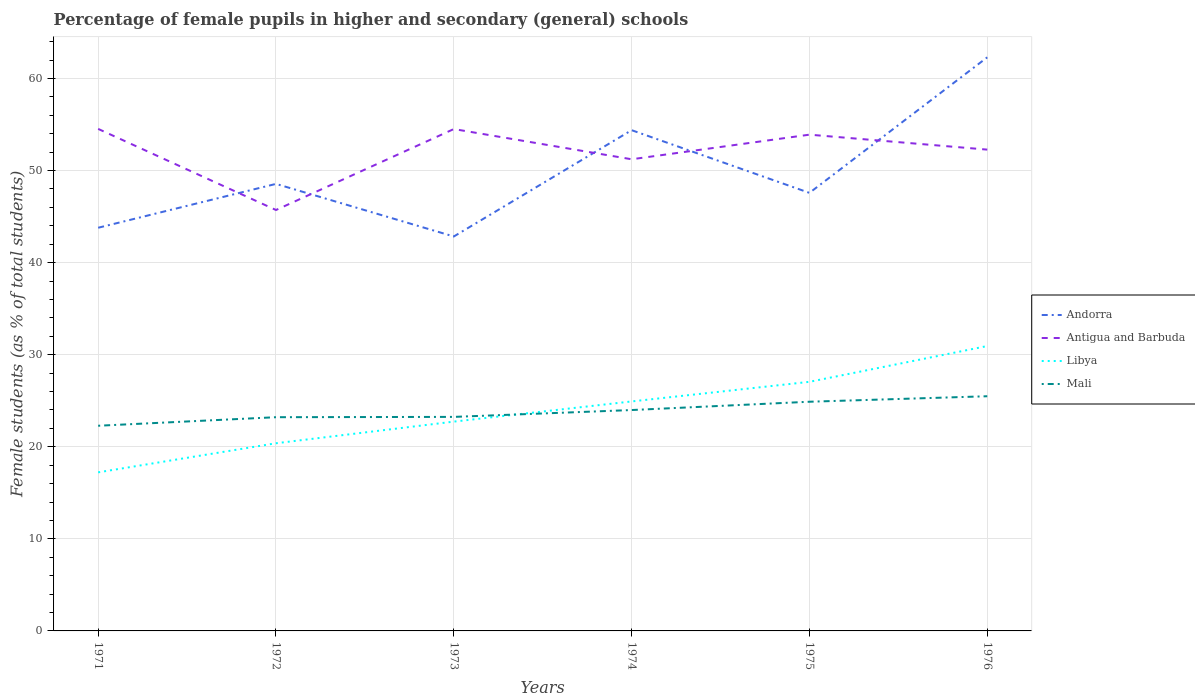Does the line corresponding to Mali intersect with the line corresponding to Libya?
Provide a succinct answer. Yes. Across all years, what is the maximum percentage of female pupils in higher and secondary schools in Andorra?
Make the answer very short. 42.84. What is the total percentage of female pupils in higher and secondary schools in Antigua and Barbuda in the graph?
Ensure brevity in your answer.  3.3. What is the difference between the highest and the second highest percentage of female pupils in higher and secondary schools in Antigua and Barbuda?
Provide a succinct answer. 8.81. What is the difference between the highest and the lowest percentage of female pupils in higher and secondary schools in Mali?
Make the answer very short. 3. How many lines are there?
Your answer should be compact. 4. How many years are there in the graph?
Offer a very short reply. 6. What is the difference between two consecutive major ticks on the Y-axis?
Your response must be concise. 10. Are the values on the major ticks of Y-axis written in scientific E-notation?
Offer a very short reply. No. Does the graph contain grids?
Give a very brief answer. Yes. Where does the legend appear in the graph?
Your answer should be very brief. Center right. How many legend labels are there?
Your answer should be very brief. 4. How are the legend labels stacked?
Your response must be concise. Vertical. What is the title of the graph?
Offer a terse response. Percentage of female pupils in higher and secondary (general) schools. What is the label or title of the Y-axis?
Make the answer very short. Female students (as % of total students). What is the Female students (as % of total students) of Andorra in 1971?
Give a very brief answer. 43.78. What is the Female students (as % of total students) of Antigua and Barbuda in 1971?
Offer a terse response. 54.52. What is the Female students (as % of total students) of Libya in 1971?
Provide a short and direct response. 17.22. What is the Female students (as % of total students) in Mali in 1971?
Offer a terse response. 22.28. What is the Female students (as % of total students) in Andorra in 1972?
Offer a very short reply. 48.55. What is the Female students (as % of total students) of Antigua and Barbuda in 1972?
Give a very brief answer. 45.71. What is the Female students (as % of total students) of Libya in 1972?
Give a very brief answer. 20.38. What is the Female students (as % of total students) of Mali in 1972?
Your response must be concise. 23.21. What is the Female students (as % of total students) of Andorra in 1973?
Make the answer very short. 42.84. What is the Female students (as % of total students) in Antigua and Barbuda in 1973?
Keep it short and to the point. 54.5. What is the Female students (as % of total students) of Libya in 1973?
Your answer should be compact. 22.73. What is the Female students (as % of total students) in Mali in 1973?
Offer a terse response. 23.24. What is the Female students (as % of total students) of Andorra in 1974?
Ensure brevity in your answer.  54.38. What is the Female students (as % of total students) of Antigua and Barbuda in 1974?
Provide a short and direct response. 51.22. What is the Female students (as % of total students) of Libya in 1974?
Your response must be concise. 24.92. What is the Female students (as % of total students) of Mali in 1974?
Provide a short and direct response. 23.99. What is the Female students (as % of total students) of Andorra in 1975?
Keep it short and to the point. 47.57. What is the Female students (as % of total students) of Antigua and Barbuda in 1975?
Your answer should be very brief. 53.89. What is the Female students (as % of total students) in Libya in 1975?
Offer a very short reply. 27.05. What is the Female students (as % of total students) of Mali in 1975?
Make the answer very short. 24.89. What is the Female students (as % of total students) of Andorra in 1976?
Provide a succinct answer. 62.29. What is the Female students (as % of total students) of Antigua and Barbuda in 1976?
Keep it short and to the point. 52.27. What is the Female students (as % of total students) in Libya in 1976?
Your response must be concise. 30.94. What is the Female students (as % of total students) of Mali in 1976?
Keep it short and to the point. 25.49. Across all years, what is the maximum Female students (as % of total students) of Andorra?
Keep it short and to the point. 62.29. Across all years, what is the maximum Female students (as % of total students) in Antigua and Barbuda?
Your answer should be compact. 54.52. Across all years, what is the maximum Female students (as % of total students) of Libya?
Make the answer very short. 30.94. Across all years, what is the maximum Female students (as % of total students) of Mali?
Your response must be concise. 25.49. Across all years, what is the minimum Female students (as % of total students) in Andorra?
Offer a very short reply. 42.84. Across all years, what is the minimum Female students (as % of total students) of Antigua and Barbuda?
Your response must be concise. 45.71. Across all years, what is the minimum Female students (as % of total students) of Libya?
Your answer should be compact. 17.22. Across all years, what is the minimum Female students (as % of total students) of Mali?
Your response must be concise. 22.28. What is the total Female students (as % of total students) in Andorra in the graph?
Your response must be concise. 299.42. What is the total Female students (as % of total students) in Antigua and Barbuda in the graph?
Provide a succinct answer. 312.12. What is the total Female students (as % of total students) of Libya in the graph?
Make the answer very short. 143.25. What is the total Female students (as % of total students) of Mali in the graph?
Provide a short and direct response. 143.1. What is the difference between the Female students (as % of total students) in Andorra in 1971 and that in 1972?
Your answer should be very brief. -4.76. What is the difference between the Female students (as % of total students) of Antigua and Barbuda in 1971 and that in 1972?
Give a very brief answer. 8.81. What is the difference between the Female students (as % of total students) of Libya in 1971 and that in 1972?
Your answer should be very brief. -3.16. What is the difference between the Female students (as % of total students) in Mali in 1971 and that in 1972?
Make the answer very short. -0.93. What is the difference between the Female students (as % of total students) in Andorra in 1971 and that in 1973?
Offer a terse response. 0.95. What is the difference between the Female students (as % of total students) of Antigua and Barbuda in 1971 and that in 1973?
Your answer should be compact. 0.02. What is the difference between the Female students (as % of total students) in Libya in 1971 and that in 1973?
Offer a terse response. -5.51. What is the difference between the Female students (as % of total students) in Mali in 1971 and that in 1973?
Give a very brief answer. -0.96. What is the difference between the Female students (as % of total students) of Andorra in 1971 and that in 1974?
Your answer should be very brief. -10.6. What is the difference between the Female students (as % of total students) of Antigua and Barbuda in 1971 and that in 1974?
Your response must be concise. 3.3. What is the difference between the Female students (as % of total students) in Libya in 1971 and that in 1974?
Your response must be concise. -7.7. What is the difference between the Female students (as % of total students) of Mali in 1971 and that in 1974?
Keep it short and to the point. -1.71. What is the difference between the Female students (as % of total students) of Andorra in 1971 and that in 1975?
Make the answer very short. -3.79. What is the difference between the Female students (as % of total students) in Antigua and Barbuda in 1971 and that in 1975?
Your answer should be very brief. 0.63. What is the difference between the Female students (as % of total students) in Libya in 1971 and that in 1975?
Offer a terse response. -9.83. What is the difference between the Female students (as % of total students) of Mali in 1971 and that in 1975?
Your answer should be very brief. -2.61. What is the difference between the Female students (as % of total students) of Andorra in 1971 and that in 1976?
Provide a succinct answer. -18.51. What is the difference between the Female students (as % of total students) in Antigua and Barbuda in 1971 and that in 1976?
Make the answer very short. 2.25. What is the difference between the Female students (as % of total students) of Libya in 1971 and that in 1976?
Ensure brevity in your answer.  -13.72. What is the difference between the Female students (as % of total students) in Mali in 1971 and that in 1976?
Make the answer very short. -3.2. What is the difference between the Female students (as % of total students) of Andorra in 1972 and that in 1973?
Offer a terse response. 5.71. What is the difference between the Female students (as % of total students) in Antigua and Barbuda in 1972 and that in 1973?
Provide a succinct answer. -8.79. What is the difference between the Female students (as % of total students) of Libya in 1972 and that in 1973?
Your response must be concise. -2.35. What is the difference between the Female students (as % of total students) in Mali in 1972 and that in 1973?
Provide a short and direct response. -0.03. What is the difference between the Female students (as % of total students) in Andorra in 1972 and that in 1974?
Provide a short and direct response. -5.83. What is the difference between the Female students (as % of total students) of Antigua and Barbuda in 1972 and that in 1974?
Provide a succinct answer. -5.51. What is the difference between the Female students (as % of total students) of Libya in 1972 and that in 1974?
Make the answer very short. -4.54. What is the difference between the Female students (as % of total students) in Mali in 1972 and that in 1974?
Provide a short and direct response. -0.78. What is the difference between the Female students (as % of total students) of Andorra in 1972 and that in 1975?
Your answer should be very brief. 0.97. What is the difference between the Female students (as % of total students) of Antigua and Barbuda in 1972 and that in 1975?
Offer a very short reply. -8.18. What is the difference between the Female students (as % of total students) in Libya in 1972 and that in 1975?
Your answer should be compact. -6.67. What is the difference between the Female students (as % of total students) of Mali in 1972 and that in 1975?
Keep it short and to the point. -1.68. What is the difference between the Female students (as % of total students) in Andorra in 1972 and that in 1976?
Your answer should be compact. -13.75. What is the difference between the Female students (as % of total students) of Antigua and Barbuda in 1972 and that in 1976?
Make the answer very short. -6.56. What is the difference between the Female students (as % of total students) in Libya in 1972 and that in 1976?
Give a very brief answer. -10.56. What is the difference between the Female students (as % of total students) of Mali in 1972 and that in 1976?
Give a very brief answer. -2.28. What is the difference between the Female students (as % of total students) in Andorra in 1973 and that in 1974?
Offer a very short reply. -11.55. What is the difference between the Female students (as % of total students) in Antigua and Barbuda in 1973 and that in 1974?
Provide a succinct answer. 3.28. What is the difference between the Female students (as % of total students) of Libya in 1973 and that in 1974?
Provide a short and direct response. -2.19. What is the difference between the Female students (as % of total students) of Mali in 1973 and that in 1974?
Your answer should be compact. -0.74. What is the difference between the Female students (as % of total students) in Andorra in 1973 and that in 1975?
Your answer should be compact. -4.74. What is the difference between the Female students (as % of total students) in Antigua and Barbuda in 1973 and that in 1975?
Ensure brevity in your answer.  0.61. What is the difference between the Female students (as % of total students) of Libya in 1973 and that in 1975?
Your response must be concise. -4.32. What is the difference between the Female students (as % of total students) in Mali in 1973 and that in 1975?
Make the answer very short. -1.65. What is the difference between the Female students (as % of total students) in Andorra in 1973 and that in 1976?
Keep it short and to the point. -19.46. What is the difference between the Female students (as % of total students) of Antigua and Barbuda in 1973 and that in 1976?
Give a very brief answer. 2.23. What is the difference between the Female students (as % of total students) of Libya in 1973 and that in 1976?
Provide a succinct answer. -8.21. What is the difference between the Female students (as % of total students) of Mali in 1973 and that in 1976?
Your answer should be compact. -2.24. What is the difference between the Female students (as % of total students) of Andorra in 1974 and that in 1975?
Provide a succinct answer. 6.81. What is the difference between the Female students (as % of total students) in Antigua and Barbuda in 1974 and that in 1975?
Keep it short and to the point. -2.67. What is the difference between the Female students (as % of total students) of Libya in 1974 and that in 1975?
Give a very brief answer. -2.13. What is the difference between the Female students (as % of total students) of Mali in 1974 and that in 1975?
Give a very brief answer. -0.9. What is the difference between the Female students (as % of total students) in Andorra in 1974 and that in 1976?
Your answer should be compact. -7.91. What is the difference between the Female students (as % of total students) in Antigua and Barbuda in 1974 and that in 1976?
Your response must be concise. -1.05. What is the difference between the Female students (as % of total students) in Libya in 1974 and that in 1976?
Ensure brevity in your answer.  -6.02. What is the difference between the Female students (as % of total students) in Mali in 1974 and that in 1976?
Provide a short and direct response. -1.5. What is the difference between the Female students (as % of total students) in Andorra in 1975 and that in 1976?
Your answer should be compact. -14.72. What is the difference between the Female students (as % of total students) of Antigua and Barbuda in 1975 and that in 1976?
Offer a very short reply. 1.62. What is the difference between the Female students (as % of total students) of Libya in 1975 and that in 1976?
Ensure brevity in your answer.  -3.89. What is the difference between the Female students (as % of total students) of Mali in 1975 and that in 1976?
Make the answer very short. -0.6. What is the difference between the Female students (as % of total students) in Andorra in 1971 and the Female students (as % of total students) in Antigua and Barbuda in 1972?
Your response must be concise. -1.93. What is the difference between the Female students (as % of total students) in Andorra in 1971 and the Female students (as % of total students) in Libya in 1972?
Give a very brief answer. 23.4. What is the difference between the Female students (as % of total students) of Andorra in 1971 and the Female students (as % of total students) of Mali in 1972?
Offer a very short reply. 20.57. What is the difference between the Female students (as % of total students) in Antigua and Barbuda in 1971 and the Female students (as % of total students) in Libya in 1972?
Offer a very short reply. 34.14. What is the difference between the Female students (as % of total students) in Antigua and Barbuda in 1971 and the Female students (as % of total students) in Mali in 1972?
Keep it short and to the point. 31.31. What is the difference between the Female students (as % of total students) in Libya in 1971 and the Female students (as % of total students) in Mali in 1972?
Give a very brief answer. -5.99. What is the difference between the Female students (as % of total students) of Andorra in 1971 and the Female students (as % of total students) of Antigua and Barbuda in 1973?
Your response must be concise. -10.72. What is the difference between the Female students (as % of total students) in Andorra in 1971 and the Female students (as % of total students) in Libya in 1973?
Make the answer very short. 21.05. What is the difference between the Female students (as % of total students) in Andorra in 1971 and the Female students (as % of total students) in Mali in 1973?
Provide a succinct answer. 20.54. What is the difference between the Female students (as % of total students) of Antigua and Barbuda in 1971 and the Female students (as % of total students) of Libya in 1973?
Keep it short and to the point. 31.79. What is the difference between the Female students (as % of total students) of Antigua and Barbuda in 1971 and the Female students (as % of total students) of Mali in 1973?
Provide a short and direct response. 31.28. What is the difference between the Female students (as % of total students) of Libya in 1971 and the Female students (as % of total students) of Mali in 1973?
Your answer should be compact. -6.02. What is the difference between the Female students (as % of total students) of Andorra in 1971 and the Female students (as % of total students) of Antigua and Barbuda in 1974?
Offer a very short reply. -7.44. What is the difference between the Female students (as % of total students) in Andorra in 1971 and the Female students (as % of total students) in Libya in 1974?
Provide a succinct answer. 18.86. What is the difference between the Female students (as % of total students) in Andorra in 1971 and the Female students (as % of total students) in Mali in 1974?
Keep it short and to the point. 19.8. What is the difference between the Female students (as % of total students) of Antigua and Barbuda in 1971 and the Female students (as % of total students) of Libya in 1974?
Your response must be concise. 29.6. What is the difference between the Female students (as % of total students) in Antigua and Barbuda in 1971 and the Female students (as % of total students) in Mali in 1974?
Keep it short and to the point. 30.53. What is the difference between the Female students (as % of total students) in Libya in 1971 and the Female students (as % of total students) in Mali in 1974?
Offer a very short reply. -6.77. What is the difference between the Female students (as % of total students) of Andorra in 1971 and the Female students (as % of total students) of Antigua and Barbuda in 1975?
Provide a succinct answer. -10.11. What is the difference between the Female students (as % of total students) of Andorra in 1971 and the Female students (as % of total students) of Libya in 1975?
Ensure brevity in your answer.  16.73. What is the difference between the Female students (as % of total students) of Andorra in 1971 and the Female students (as % of total students) of Mali in 1975?
Provide a short and direct response. 18.89. What is the difference between the Female students (as % of total students) of Antigua and Barbuda in 1971 and the Female students (as % of total students) of Libya in 1975?
Offer a very short reply. 27.47. What is the difference between the Female students (as % of total students) in Antigua and Barbuda in 1971 and the Female students (as % of total students) in Mali in 1975?
Ensure brevity in your answer.  29.63. What is the difference between the Female students (as % of total students) of Libya in 1971 and the Female students (as % of total students) of Mali in 1975?
Make the answer very short. -7.67. What is the difference between the Female students (as % of total students) of Andorra in 1971 and the Female students (as % of total students) of Antigua and Barbuda in 1976?
Your answer should be compact. -8.49. What is the difference between the Female students (as % of total students) in Andorra in 1971 and the Female students (as % of total students) in Libya in 1976?
Your answer should be compact. 12.85. What is the difference between the Female students (as % of total students) of Andorra in 1971 and the Female students (as % of total students) of Mali in 1976?
Provide a succinct answer. 18.3. What is the difference between the Female students (as % of total students) of Antigua and Barbuda in 1971 and the Female students (as % of total students) of Libya in 1976?
Keep it short and to the point. 23.58. What is the difference between the Female students (as % of total students) in Antigua and Barbuda in 1971 and the Female students (as % of total students) in Mali in 1976?
Your answer should be very brief. 29.03. What is the difference between the Female students (as % of total students) in Libya in 1971 and the Female students (as % of total students) in Mali in 1976?
Your answer should be very brief. -8.26. What is the difference between the Female students (as % of total students) of Andorra in 1972 and the Female students (as % of total students) of Antigua and Barbuda in 1973?
Your answer should be very brief. -5.96. What is the difference between the Female students (as % of total students) of Andorra in 1972 and the Female students (as % of total students) of Libya in 1973?
Give a very brief answer. 25.82. What is the difference between the Female students (as % of total students) in Andorra in 1972 and the Female students (as % of total students) in Mali in 1973?
Your response must be concise. 25.3. What is the difference between the Female students (as % of total students) of Antigua and Barbuda in 1972 and the Female students (as % of total students) of Libya in 1973?
Provide a succinct answer. 22.98. What is the difference between the Female students (as % of total students) in Antigua and Barbuda in 1972 and the Female students (as % of total students) in Mali in 1973?
Provide a succinct answer. 22.47. What is the difference between the Female students (as % of total students) of Libya in 1972 and the Female students (as % of total students) of Mali in 1973?
Your answer should be compact. -2.86. What is the difference between the Female students (as % of total students) of Andorra in 1972 and the Female students (as % of total students) of Antigua and Barbuda in 1974?
Offer a very short reply. -2.67. What is the difference between the Female students (as % of total students) in Andorra in 1972 and the Female students (as % of total students) in Libya in 1974?
Offer a terse response. 23.62. What is the difference between the Female students (as % of total students) in Andorra in 1972 and the Female students (as % of total students) in Mali in 1974?
Keep it short and to the point. 24.56. What is the difference between the Female students (as % of total students) of Antigua and Barbuda in 1972 and the Female students (as % of total students) of Libya in 1974?
Keep it short and to the point. 20.79. What is the difference between the Female students (as % of total students) of Antigua and Barbuda in 1972 and the Female students (as % of total students) of Mali in 1974?
Provide a succinct answer. 21.72. What is the difference between the Female students (as % of total students) in Libya in 1972 and the Female students (as % of total students) in Mali in 1974?
Make the answer very short. -3.61. What is the difference between the Female students (as % of total students) of Andorra in 1972 and the Female students (as % of total students) of Antigua and Barbuda in 1975?
Give a very brief answer. -5.35. What is the difference between the Female students (as % of total students) in Andorra in 1972 and the Female students (as % of total students) in Libya in 1975?
Keep it short and to the point. 21.5. What is the difference between the Female students (as % of total students) of Andorra in 1972 and the Female students (as % of total students) of Mali in 1975?
Provide a succinct answer. 23.66. What is the difference between the Female students (as % of total students) in Antigua and Barbuda in 1972 and the Female students (as % of total students) in Libya in 1975?
Keep it short and to the point. 18.66. What is the difference between the Female students (as % of total students) of Antigua and Barbuda in 1972 and the Female students (as % of total students) of Mali in 1975?
Provide a short and direct response. 20.82. What is the difference between the Female students (as % of total students) of Libya in 1972 and the Female students (as % of total students) of Mali in 1975?
Your answer should be very brief. -4.51. What is the difference between the Female students (as % of total students) of Andorra in 1972 and the Female students (as % of total students) of Antigua and Barbuda in 1976?
Your response must be concise. -3.72. What is the difference between the Female students (as % of total students) in Andorra in 1972 and the Female students (as % of total students) in Libya in 1976?
Offer a terse response. 17.61. What is the difference between the Female students (as % of total students) in Andorra in 1972 and the Female students (as % of total students) in Mali in 1976?
Your answer should be compact. 23.06. What is the difference between the Female students (as % of total students) of Antigua and Barbuda in 1972 and the Female students (as % of total students) of Libya in 1976?
Your response must be concise. 14.77. What is the difference between the Female students (as % of total students) in Antigua and Barbuda in 1972 and the Female students (as % of total students) in Mali in 1976?
Provide a succinct answer. 20.23. What is the difference between the Female students (as % of total students) of Libya in 1972 and the Female students (as % of total students) of Mali in 1976?
Your answer should be very brief. -5.11. What is the difference between the Female students (as % of total students) of Andorra in 1973 and the Female students (as % of total students) of Antigua and Barbuda in 1974?
Keep it short and to the point. -8.39. What is the difference between the Female students (as % of total students) of Andorra in 1973 and the Female students (as % of total students) of Libya in 1974?
Ensure brevity in your answer.  17.91. What is the difference between the Female students (as % of total students) in Andorra in 1973 and the Female students (as % of total students) in Mali in 1974?
Ensure brevity in your answer.  18.85. What is the difference between the Female students (as % of total students) in Antigua and Barbuda in 1973 and the Female students (as % of total students) in Libya in 1974?
Ensure brevity in your answer.  29.58. What is the difference between the Female students (as % of total students) in Antigua and Barbuda in 1973 and the Female students (as % of total students) in Mali in 1974?
Your answer should be very brief. 30.52. What is the difference between the Female students (as % of total students) in Libya in 1973 and the Female students (as % of total students) in Mali in 1974?
Your answer should be compact. -1.26. What is the difference between the Female students (as % of total students) of Andorra in 1973 and the Female students (as % of total students) of Antigua and Barbuda in 1975?
Provide a succinct answer. -11.06. What is the difference between the Female students (as % of total students) in Andorra in 1973 and the Female students (as % of total students) in Libya in 1975?
Offer a very short reply. 15.78. What is the difference between the Female students (as % of total students) in Andorra in 1973 and the Female students (as % of total students) in Mali in 1975?
Your answer should be very brief. 17.95. What is the difference between the Female students (as % of total students) of Antigua and Barbuda in 1973 and the Female students (as % of total students) of Libya in 1975?
Give a very brief answer. 27.45. What is the difference between the Female students (as % of total students) of Antigua and Barbuda in 1973 and the Female students (as % of total students) of Mali in 1975?
Provide a succinct answer. 29.61. What is the difference between the Female students (as % of total students) in Libya in 1973 and the Female students (as % of total students) in Mali in 1975?
Make the answer very short. -2.16. What is the difference between the Female students (as % of total students) of Andorra in 1973 and the Female students (as % of total students) of Antigua and Barbuda in 1976?
Provide a succinct answer. -9.43. What is the difference between the Female students (as % of total students) of Andorra in 1973 and the Female students (as % of total students) of Libya in 1976?
Your answer should be very brief. 11.9. What is the difference between the Female students (as % of total students) in Andorra in 1973 and the Female students (as % of total students) in Mali in 1976?
Give a very brief answer. 17.35. What is the difference between the Female students (as % of total students) of Antigua and Barbuda in 1973 and the Female students (as % of total students) of Libya in 1976?
Your response must be concise. 23.57. What is the difference between the Female students (as % of total students) in Antigua and Barbuda in 1973 and the Female students (as % of total students) in Mali in 1976?
Give a very brief answer. 29.02. What is the difference between the Female students (as % of total students) of Libya in 1973 and the Female students (as % of total students) of Mali in 1976?
Your answer should be compact. -2.76. What is the difference between the Female students (as % of total students) of Andorra in 1974 and the Female students (as % of total students) of Antigua and Barbuda in 1975?
Give a very brief answer. 0.49. What is the difference between the Female students (as % of total students) in Andorra in 1974 and the Female students (as % of total students) in Libya in 1975?
Give a very brief answer. 27.33. What is the difference between the Female students (as % of total students) in Andorra in 1974 and the Female students (as % of total students) in Mali in 1975?
Give a very brief answer. 29.49. What is the difference between the Female students (as % of total students) of Antigua and Barbuda in 1974 and the Female students (as % of total students) of Libya in 1975?
Your response must be concise. 24.17. What is the difference between the Female students (as % of total students) of Antigua and Barbuda in 1974 and the Female students (as % of total students) of Mali in 1975?
Ensure brevity in your answer.  26.33. What is the difference between the Female students (as % of total students) in Libya in 1974 and the Female students (as % of total students) in Mali in 1975?
Ensure brevity in your answer.  0.03. What is the difference between the Female students (as % of total students) in Andorra in 1974 and the Female students (as % of total students) in Antigua and Barbuda in 1976?
Provide a succinct answer. 2.11. What is the difference between the Female students (as % of total students) in Andorra in 1974 and the Female students (as % of total students) in Libya in 1976?
Your answer should be compact. 23.44. What is the difference between the Female students (as % of total students) of Andorra in 1974 and the Female students (as % of total students) of Mali in 1976?
Your response must be concise. 28.9. What is the difference between the Female students (as % of total students) of Antigua and Barbuda in 1974 and the Female students (as % of total students) of Libya in 1976?
Provide a succinct answer. 20.28. What is the difference between the Female students (as % of total students) in Antigua and Barbuda in 1974 and the Female students (as % of total students) in Mali in 1976?
Provide a succinct answer. 25.74. What is the difference between the Female students (as % of total students) in Libya in 1974 and the Female students (as % of total students) in Mali in 1976?
Provide a succinct answer. -0.56. What is the difference between the Female students (as % of total students) in Andorra in 1975 and the Female students (as % of total students) in Antigua and Barbuda in 1976?
Make the answer very short. -4.7. What is the difference between the Female students (as % of total students) of Andorra in 1975 and the Female students (as % of total students) of Libya in 1976?
Keep it short and to the point. 16.63. What is the difference between the Female students (as % of total students) of Andorra in 1975 and the Female students (as % of total students) of Mali in 1976?
Give a very brief answer. 22.09. What is the difference between the Female students (as % of total students) of Antigua and Barbuda in 1975 and the Female students (as % of total students) of Libya in 1976?
Offer a very short reply. 22.96. What is the difference between the Female students (as % of total students) in Antigua and Barbuda in 1975 and the Female students (as % of total students) in Mali in 1976?
Offer a terse response. 28.41. What is the difference between the Female students (as % of total students) in Libya in 1975 and the Female students (as % of total students) in Mali in 1976?
Provide a short and direct response. 1.57. What is the average Female students (as % of total students) in Andorra per year?
Keep it short and to the point. 49.9. What is the average Female students (as % of total students) of Antigua and Barbuda per year?
Make the answer very short. 52.02. What is the average Female students (as % of total students) of Libya per year?
Your answer should be compact. 23.87. What is the average Female students (as % of total students) of Mali per year?
Offer a very short reply. 23.85. In the year 1971, what is the difference between the Female students (as % of total students) of Andorra and Female students (as % of total students) of Antigua and Barbuda?
Ensure brevity in your answer.  -10.74. In the year 1971, what is the difference between the Female students (as % of total students) of Andorra and Female students (as % of total students) of Libya?
Give a very brief answer. 26.56. In the year 1971, what is the difference between the Female students (as % of total students) in Andorra and Female students (as % of total students) in Mali?
Ensure brevity in your answer.  21.5. In the year 1971, what is the difference between the Female students (as % of total students) in Antigua and Barbuda and Female students (as % of total students) in Libya?
Make the answer very short. 37.3. In the year 1971, what is the difference between the Female students (as % of total students) of Antigua and Barbuda and Female students (as % of total students) of Mali?
Offer a terse response. 32.24. In the year 1971, what is the difference between the Female students (as % of total students) of Libya and Female students (as % of total students) of Mali?
Offer a very short reply. -5.06. In the year 1972, what is the difference between the Female students (as % of total students) of Andorra and Female students (as % of total students) of Antigua and Barbuda?
Your answer should be very brief. 2.84. In the year 1972, what is the difference between the Female students (as % of total students) in Andorra and Female students (as % of total students) in Libya?
Give a very brief answer. 28.17. In the year 1972, what is the difference between the Female students (as % of total students) of Andorra and Female students (as % of total students) of Mali?
Your answer should be very brief. 25.34. In the year 1972, what is the difference between the Female students (as % of total students) in Antigua and Barbuda and Female students (as % of total students) in Libya?
Offer a terse response. 25.33. In the year 1972, what is the difference between the Female students (as % of total students) of Antigua and Barbuda and Female students (as % of total students) of Mali?
Make the answer very short. 22.5. In the year 1972, what is the difference between the Female students (as % of total students) of Libya and Female students (as % of total students) of Mali?
Ensure brevity in your answer.  -2.83. In the year 1973, what is the difference between the Female students (as % of total students) of Andorra and Female students (as % of total students) of Antigua and Barbuda?
Make the answer very short. -11.67. In the year 1973, what is the difference between the Female students (as % of total students) of Andorra and Female students (as % of total students) of Libya?
Offer a terse response. 20.11. In the year 1973, what is the difference between the Female students (as % of total students) of Andorra and Female students (as % of total students) of Mali?
Make the answer very short. 19.59. In the year 1973, what is the difference between the Female students (as % of total students) in Antigua and Barbuda and Female students (as % of total students) in Libya?
Provide a short and direct response. 31.77. In the year 1973, what is the difference between the Female students (as % of total students) in Antigua and Barbuda and Female students (as % of total students) in Mali?
Offer a terse response. 31.26. In the year 1973, what is the difference between the Female students (as % of total students) of Libya and Female students (as % of total students) of Mali?
Offer a terse response. -0.51. In the year 1974, what is the difference between the Female students (as % of total students) of Andorra and Female students (as % of total students) of Antigua and Barbuda?
Provide a short and direct response. 3.16. In the year 1974, what is the difference between the Female students (as % of total students) in Andorra and Female students (as % of total students) in Libya?
Provide a succinct answer. 29.46. In the year 1974, what is the difference between the Female students (as % of total students) of Andorra and Female students (as % of total students) of Mali?
Make the answer very short. 30.39. In the year 1974, what is the difference between the Female students (as % of total students) of Antigua and Barbuda and Female students (as % of total students) of Libya?
Give a very brief answer. 26.3. In the year 1974, what is the difference between the Female students (as % of total students) in Antigua and Barbuda and Female students (as % of total students) in Mali?
Your answer should be very brief. 27.23. In the year 1974, what is the difference between the Female students (as % of total students) in Libya and Female students (as % of total students) in Mali?
Give a very brief answer. 0.93. In the year 1975, what is the difference between the Female students (as % of total students) of Andorra and Female students (as % of total students) of Antigua and Barbuda?
Make the answer very short. -6.32. In the year 1975, what is the difference between the Female students (as % of total students) of Andorra and Female students (as % of total students) of Libya?
Ensure brevity in your answer.  20.52. In the year 1975, what is the difference between the Female students (as % of total students) of Andorra and Female students (as % of total students) of Mali?
Offer a terse response. 22.68. In the year 1975, what is the difference between the Female students (as % of total students) of Antigua and Barbuda and Female students (as % of total students) of Libya?
Offer a very short reply. 26.84. In the year 1975, what is the difference between the Female students (as % of total students) in Antigua and Barbuda and Female students (as % of total students) in Mali?
Provide a short and direct response. 29. In the year 1975, what is the difference between the Female students (as % of total students) of Libya and Female students (as % of total students) of Mali?
Offer a terse response. 2.16. In the year 1976, what is the difference between the Female students (as % of total students) of Andorra and Female students (as % of total students) of Antigua and Barbuda?
Ensure brevity in your answer.  10.02. In the year 1976, what is the difference between the Female students (as % of total students) in Andorra and Female students (as % of total students) in Libya?
Provide a succinct answer. 31.35. In the year 1976, what is the difference between the Female students (as % of total students) in Andorra and Female students (as % of total students) in Mali?
Give a very brief answer. 36.81. In the year 1976, what is the difference between the Female students (as % of total students) of Antigua and Barbuda and Female students (as % of total students) of Libya?
Offer a terse response. 21.33. In the year 1976, what is the difference between the Female students (as % of total students) of Antigua and Barbuda and Female students (as % of total students) of Mali?
Make the answer very short. 26.78. In the year 1976, what is the difference between the Female students (as % of total students) in Libya and Female students (as % of total students) in Mali?
Your answer should be compact. 5.45. What is the ratio of the Female students (as % of total students) of Andorra in 1971 to that in 1972?
Your answer should be very brief. 0.9. What is the ratio of the Female students (as % of total students) in Antigua and Barbuda in 1971 to that in 1972?
Your answer should be very brief. 1.19. What is the ratio of the Female students (as % of total students) in Libya in 1971 to that in 1972?
Ensure brevity in your answer.  0.84. What is the ratio of the Female students (as % of total students) of Andorra in 1971 to that in 1973?
Ensure brevity in your answer.  1.02. What is the ratio of the Female students (as % of total students) of Antigua and Barbuda in 1971 to that in 1973?
Your answer should be compact. 1. What is the ratio of the Female students (as % of total students) of Libya in 1971 to that in 1973?
Keep it short and to the point. 0.76. What is the ratio of the Female students (as % of total students) in Mali in 1971 to that in 1973?
Your response must be concise. 0.96. What is the ratio of the Female students (as % of total students) of Andorra in 1971 to that in 1974?
Offer a terse response. 0.81. What is the ratio of the Female students (as % of total students) of Antigua and Barbuda in 1971 to that in 1974?
Offer a very short reply. 1.06. What is the ratio of the Female students (as % of total students) of Libya in 1971 to that in 1974?
Provide a succinct answer. 0.69. What is the ratio of the Female students (as % of total students) of Mali in 1971 to that in 1974?
Ensure brevity in your answer.  0.93. What is the ratio of the Female students (as % of total students) of Andorra in 1971 to that in 1975?
Your answer should be very brief. 0.92. What is the ratio of the Female students (as % of total students) of Antigua and Barbuda in 1971 to that in 1975?
Ensure brevity in your answer.  1.01. What is the ratio of the Female students (as % of total students) in Libya in 1971 to that in 1975?
Your response must be concise. 0.64. What is the ratio of the Female students (as % of total students) of Mali in 1971 to that in 1975?
Your response must be concise. 0.9. What is the ratio of the Female students (as % of total students) of Andorra in 1971 to that in 1976?
Your answer should be compact. 0.7. What is the ratio of the Female students (as % of total students) in Antigua and Barbuda in 1971 to that in 1976?
Your answer should be compact. 1.04. What is the ratio of the Female students (as % of total students) in Libya in 1971 to that in 1976?
Give a very brief answer. 0.56. What is the ratio of the Female students (as % of total students) in Mali in 1971 to that in 1976?
Provide a succinct answer. 0.87. What is the ratio of the Female students (as % of total students) of Andorra in 1972 to that in 1973?
Your answer should be very brief. 1.13. What is the ratio of the Female students (as % of total students) of Antigua and Barbuda in 1972 to that in 1973?
Offer a terse response. 0.84. What is the ratio of the Female students (as % of total students) in Libya in 1972 to that in 1973?
Provide a succinct answer. 0.9. What is the ratio of the Female students (as % of total students) of Andorra in 1972 to that in 1974?
Offer a very short reply. 0.89. What is the ratio of the Female students (as % of total students) in Antigua and Barbuda in 1972 to that in 1974?
Your answer should be very brief. 0.89. What is the ratio of the Female students (as % of total students) of Libya in 1972 to that in 1974?
Ensure brevity in your answer.  0.82. What is the ratio of the Female students (as % of total students) in Mali in 1972 to that in 1974?
Make the answer very short. 0.97. What is the ratio of the Female students (as % of total students) of Andorra in 1972 to that in 1975?
Your answer should be compact. 1.02. What is the ratio of the Female students (as % of total students) of Antigua and Barbuda in 1972 to that in 1975?
Your answer should be compact. 0.85. What is the ratio of the Female students (as % of total students) in Libya in 1972 to that in 1975?
Provide a succinct answer. 0.75. What is the ratio of the Female students (as % of total students) of Mali in 1972 to that in 1975?
Offer a terse response. 0.93. What is the ratio of the Female students (as % of total students) in Andorra in 1972 to that in 1976?
Your answer should be compact. 0.78. What is the ratio of the Female students (as % of total students) of Antigua and Barbuda in 1972 to that in 1976?
Your answer should be compact. 0.87. What is the ratio of the Female students (as % of total students) in Libya in 1972 to that in 1976?
Offer a terse response. 0.66. What is the ratio of the Female students (as % of total students) in Mali in 1972 to that in 1976?
Provide a short and direct response. 0.91. What is the ratio of the Female students (as % of total students) in Andorra in 1973 to that in 1974?
Offer a very short reply. 0.79. What is the ratio of the Female students (as % of total students) of Antigua and Barbuda in 1973 to that in 1974?
Your response must be concise. 1.06. What is the ratio of the Female students (as % of total students) in Libya in 1973 to that in 1974?
Give a very brief answer. 0.91. What is the ratio of the Female students (as % of total students) of Andorra in 1973 to that in 1975?
Make the answer very short. 0.9. What is the ratio of the Female students (as % of total students) in Antigua and Barbuda in 1973 to that in 1975?
Provide a succinct answer. 1.01. What is the ratio of the Female students (as % of total students) of Libya in 1973 to that in 1975?
Provide a succinct answer. 0.84. What is the ratio of the Female students (as % of total students) in Mali in 1973 to that in 1975?
Provide a short and direct response. 0.93. What is the ratio of the Female students (as % of total students) in Andorra in 1973 to that in 1976?
Provide a succinct answer. 0.69. What is the ratio of the Female students (as % of total students) in Antigua and Barbuda in 1973 to that in 1976?
Offer a terse response. 1.04. What is the ratio of the Female students (as % of total students) in Libya in 1973 to that in 1976?
Provide a short and direct response. 0.73. What is the ratio of the Female students (as % of total students) of Mali in 1973 to that in 1976?
Provide a short and direct response. 0.91. What is the ratio of the Female students (as % of total students) in Andorra in 1974 to that in 1975?
Your response must be concise. 1.14. What is the ratio of the Female students (as % of total students) of Antigua and Barbuda in 1974 to that in 1975?
Offer a terse response. 0.95. What is the ratio of the Female students (as % of total students) in Libya in 1974 to that in 1975?
Your answer should be very brief. 0.92. What is the ratio of the Female students (as % of total students) of Mali in 1974 to that in 1975?
Your answer should be compact. 0.96. What is the ratio of the Female students (as % of total students) in Andorra in 1974 to that in 1976?
Offer a terse response. 0.87. What is the ratio of the Female students (as % of total students) in Antigua and Barbuda in 1974 to that in 1976?
Provide a succinct answer. 0.98. What is the ratio of the Female students (as % of total students) in Libya in 1974 to that in 1976?
Ensure brevity in your answer.  0.81. What is the ratio of the Female students (as % of total students) in Mali in 1974 to that in 1976?
Give a very brief answer. 0.94. What is the ratio of the Female students (as % of total students) in Andorra in 1975 to that in 1976?
Provide a succinct answer. 0.76. What is the ratio of the Female students (as % of total students) in Antigua and Barbuda in 1975 to that in 1976?
Offer a very short reply. 1.03. What is the ratio of the Female students (as % of total students) of Libya in 1975 to that in 1976?
Offer a terse response. 0.87. What is the ratio of the Female students (as % of total students) in Mali in 1975 to that in 1976?
Provide a short and direct response. 0.98. What is the difference between the highest and the second highest Female students (as % of total students) of Andorra?
Your answer should be compact. 7.91. What is the difference between the highest and the second highest Female students (as % of total students) of Antigua and Barbuda?
Give a very brief answer. 0.02. What is the difference between the highest and the second highest Female students (as % of total students) of Libya?
Your response must be concise. 3.89. What is the difference between the highest and the second highest Female students (as % of total students) of Mali?
Keep it short and to the point. 0.6. What is the difference between the highest and the lowest Female students (as % of total students) of Andorra?
Provide a short and direct response. 19.46. What is the difference between the highest and the lowest Female students (as % of total students) in Antigua and Barbuda?
Give a very brief answer. 8.81. What is the difference between the highest and the lowest Female students (as % of total students) in Libya?
Your answer should be compact. 13.72. What is the difference between the highest and the lowest Female students (as % of total students) of Mali?
Provide a short and direct response. 3.2. 